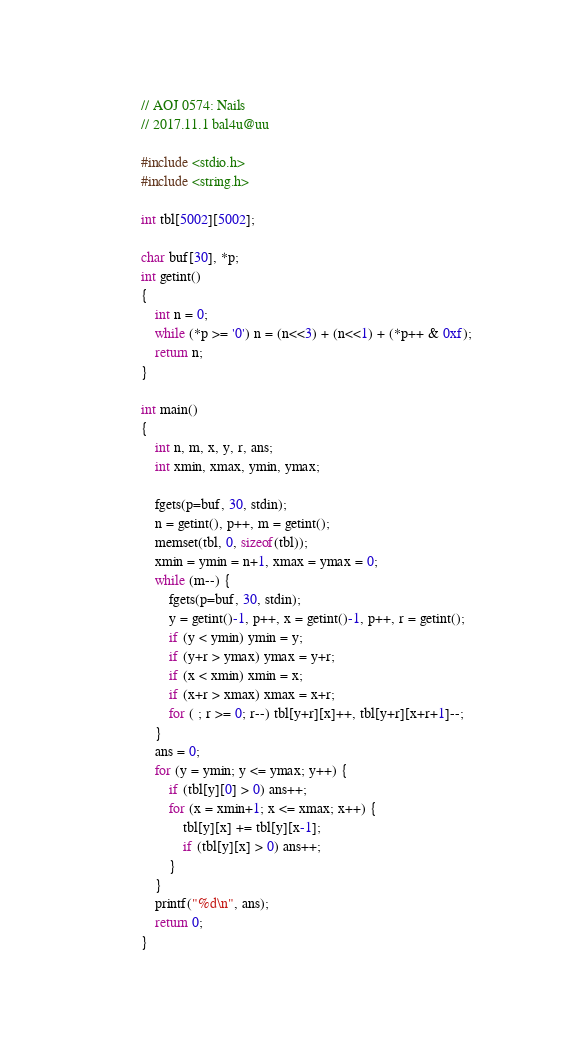<code> <loc_0><loc_0><loc_500><loc_500><_C_>// AOJ 0574: Nails
// 2017.11.1 bal4u@uu

#include <stdio.h>
#include <string.h>

int tbl[5002][5002];

char buf[30], *p;
int getint()
{
	int n = 0;
	while (*p >= '0') n = (n<<3) + (n<<1) + (*p++ & 0xf);
	return n;
}

int main()
{
    int n, m, x, y, r, ans;
	int xmin, xmax, ymin, ymax;

    fgets(p=buf, 30, stdin);
	n = getint(), p++, m = getint();
	memset(tbl, 0, sizeof(tbl));
	xmin = ymin = n+1, xmax = ymax = 0;
	while (m--) {
		fgets(p=buf, 30, stdin);
		y = getint()-1, p++, x = getint()-1, p++, r = getint();
		if (y < ymin) ymin = y;
		if (y+r > ymax) ymax = y+r;
		if (x < xmin) xmin = x;
		if (x+r > xmax) xmax = x+r;
		for ( ; r >= 0; r--) tbl[y+r][x]++, tbl[y+r][x+r+1]--;
	}
	ans = 0;
	for (y = ymin; y <= ymax; y++) {
		if (tbl[y][0] > 0) ans++;
		for (x = xmin+1; x <= xmax; x++) {
			tbl[y][x] += tbl[y][x-1];
			if (tbl[y][x] > 0) ans++;
		}
	}
	printf("%d\n", ans);
    return 0;
}</code> 